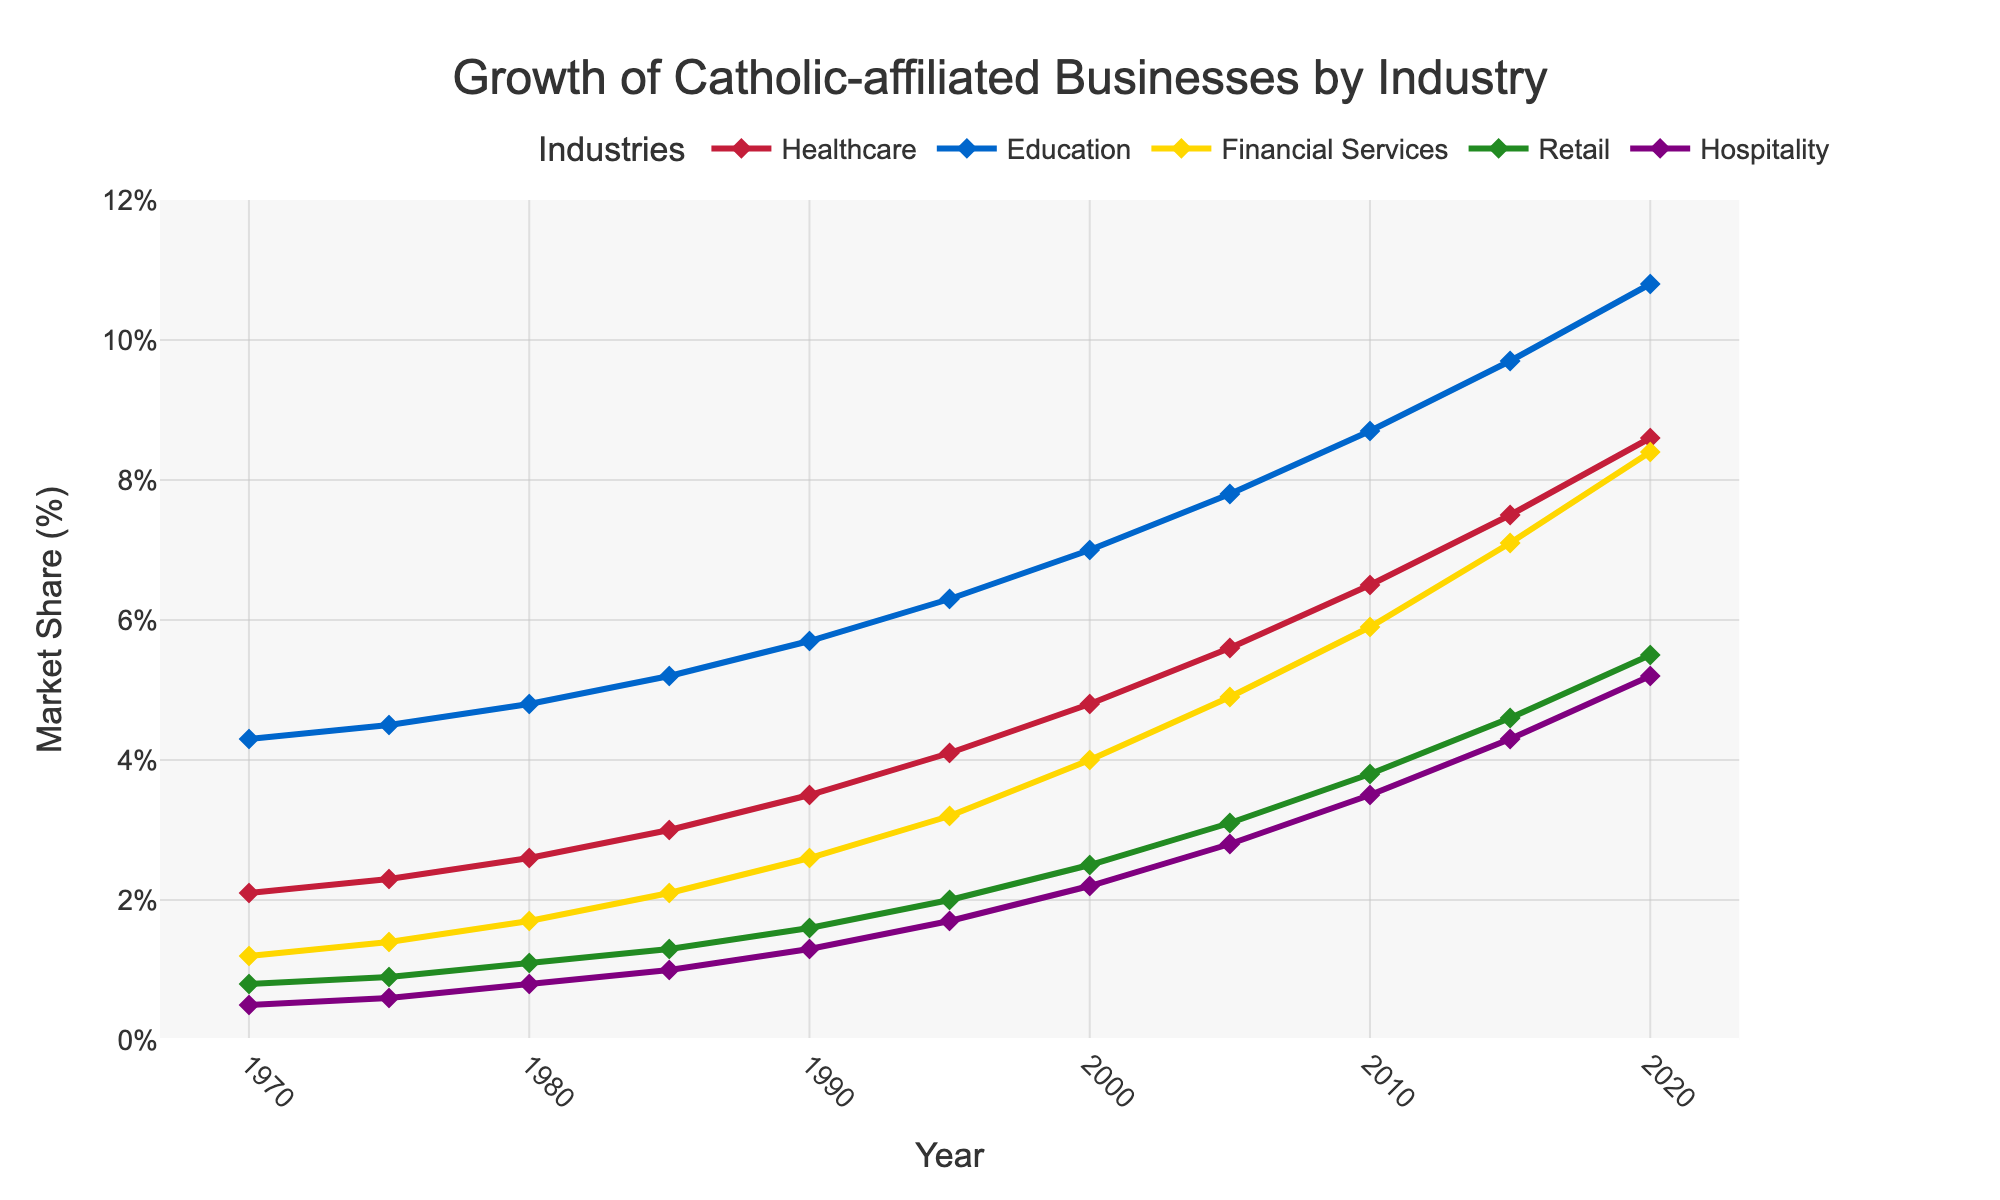Which industry had the highest market share in 2020? In the plot, the industry with the highest market share in 2020 is identified by looking at the y-axis value for each line at the 2020 mark. Education has the highest value.
Answer: Education How much did the market share of Healthcare increase from 1970 to 2020? To determine the increase, subtract the market share of Healthcare in 1970 from its market share in 2020 (8.6% - 2.1%).
Answer: 6.5% Which two industries had the smallest gap in market share in 1990? Identify the market shares of each industry in 1990 from the plot and calculate the differences between each pair. The smallest difference is between Financial Services (2.6) and Retail (1.6), which is 1.0.
Answer: Financial Services and Retail What is the average market share of Financial Services over the decades shown? The market share of Financial Services in each decade is extracted and summed up (1.2 + 1.4 + 1.7 + 2.1 + 2.6 + 3.2 + 4.0 + 4.9 + 5.9 + 7.1 + 8.4 = 42.5). The sum is then divided by the number of decades (11), so 42.5 / 11.
Answer: 3.86% What can be said about the trend of Retail market share over time? Observing the plot, the Retail market share shows a steady increase over the years, starting from 0.8% in 1970 and reaching 5.5% in 2020.
Answer: Steady increase Which industry had the fastest growth rate from 2000 to 2020? Calculate the rate of increase by comparing the market shares in 2000 and 2020 for each industry. The industry with the largest increase is Healthcare (8.6% - 4.8% = 3.8).
Answer: Healthcare In which decade did Hospitality experience its largest percentage growth? Calculate the percentage growth for each decade (new value - old value) / old value * 100. The largest percentage growth for Hospitality is from 0.5% to 0.8% between 1970 and 1980, which is a 60% increase.
Answer: 1970 to 1980 Which industries had a market share of over 7% in 2015? By examining the y-axis values for each industry in 2015, industries with a market share over 7% are identified. They are Healthcare, Education, and Financial Services.
Answer: Healthcare, Education, and Financial Services What can be inferred about the change in market share for Education between 1980 and 1990? Observe the plot and note the y-axis values for Education in 1980 (4.8%) and 1990 (5.7%). Calculate the increase (5.7% - 4.8% = 0.9%), indicating a consistent upward trend.
Answer: 0.9% increase 